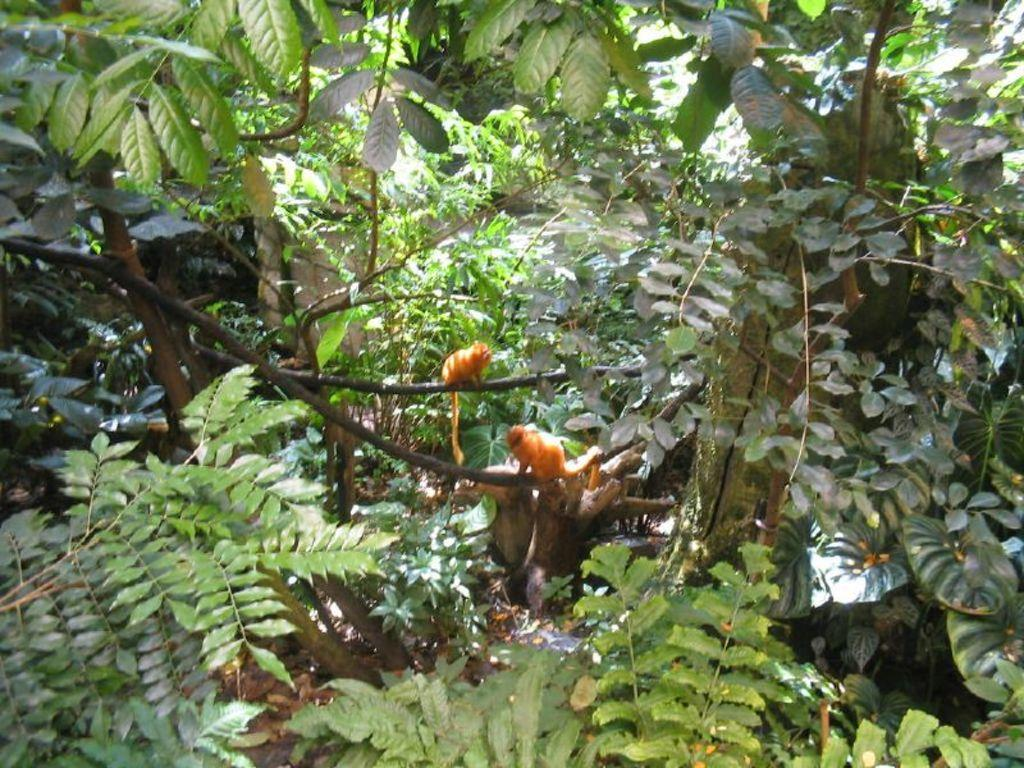What animals are featured in the image? There are two golden lions in the image. Where are the lions sitting? The lions are sitting on a tree. What can be seen in the background of the image? There are leaves and stones in the background of the image. What flavor of ice cream does the son enjoy at the harbor in the image? There is no ice cream, son, or harbor present in the image; it features two golden lions sitting on a tree with leaves and stones in the background. 